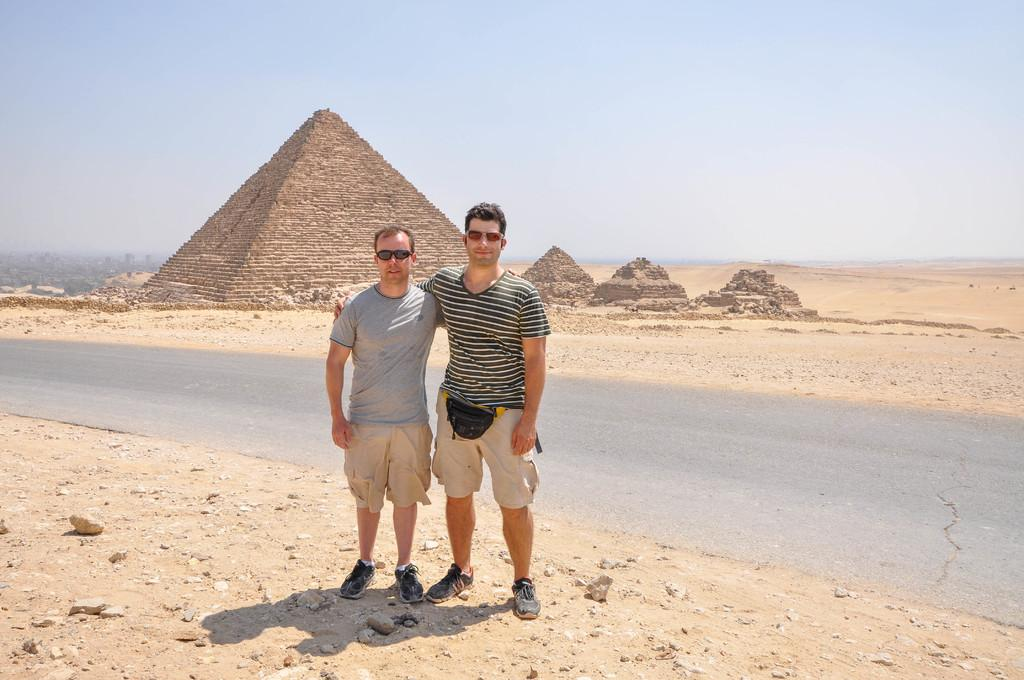What is happening in the center of the image? There are men on the ground in the center of the image. What can be seen in the background of the image? There is a road, pyramids, sand, and the sky visible in the background. Can you describe the terrain in the background? The background features sand, which suggests a desert-like environment. What type of loaf is being used as a musical instrument by the men in the image? There is no loaf or musical instrument present in the image; the men are simply standing on the ground. Is there a sheet covering the pyramids in the background? There is no sheet visible in the image; the pyramids are exposed in the background. 